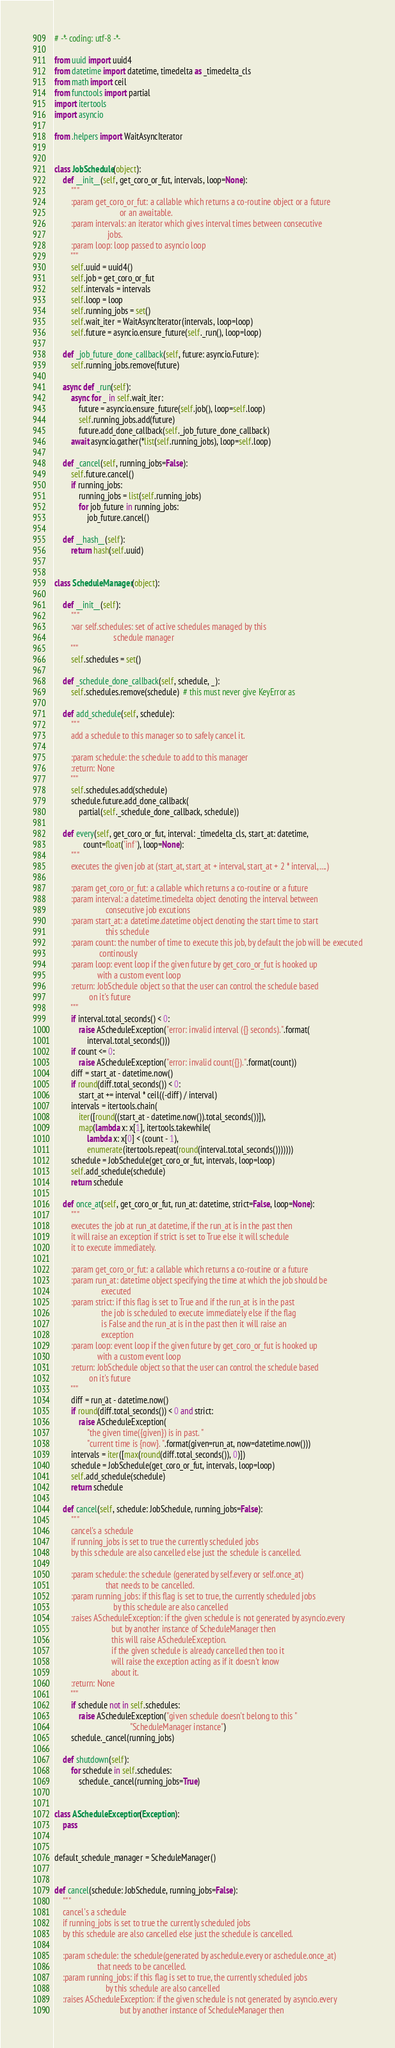<code> <loc_0><loc_0><loc_500><loc_500><_Python_># -*- coding: utf-8 -*-

from uuid import uuid4
from datetime import datetime, timedelta as _timedelta_cls
from math import ceil
from functools import partial
import itertools
import asyncio

from .helpers import WaitAsyncIterator


class JobSchedule(object):
    def __init__(self, get_coro_or_fut, intervals, loop=None):
        """
        :param get_coro_or_fut: a callable which returns a co-routine object or a future
                                or an awaitable.
        :param intervals: an iterator which gives interval times between consecutive
                          jobs.
        :param loop: loop passed to asyncio loop
        """
        self.uuid = uuid4()
        self.job = get_coro_or_fut
        self.intervals = intervals
        self.loop = loop
        self.running_jobs = set()
        self.wait_iter = WaitAsyncIterator(intervals, loop=loop)
        self.future = asyncio.ensure_future(self._run(), loop=loop)

    def _job_future_done_callback(self, future: asyncio.Future):
        self.running_jobs.remove(future)

    async def _run(self):
        async for _ in self.wait_iter:
            future = asyncio.ensure_future(self.job(), loop=self.loop)
            self.running_jobs.add(future)
            future.add_done_callback(self._job_future_done_callback)
        await asyncio.gather(*list(self.running_jobs), loop=self.loop)

    def _cancel(self, running_jobs=False):
        self.future.cancel()
        if running_jobs:
            running_jobs = list(self.running_jobs)
            for job_future in running_jobs:
                job_future.cancel()

    def __hash__(self):
        return hash(self.uuid)


class ScheduleManager(object):

    def __init__(self):
        """
        :var self.schedules: set of active schedules managed by this
                             schedule manager
        """
        self.schedules = set()

    def _schedule_done_callback(self, schedule, _):
        self.schedules.remove(schedule)  # this must never give KeyError as

    def add_schedule(self, schedule):
        """
        add a schedule to this manager so to safely cancel it.

        :param schedule: the schedule to add to this manager
        :return: None
        """
        self.schedules.add(schedule)
        schedule.future.add_done_callback(
            partial(self._schedule_done_callback, schedule))

    def every(self, get_coro_or_fut, interval: _timedelta_cls, start_at: datetime,
              count=float('inf'), loop=None):
        """
        executes the given job at (start_at, start_at + interval, start_at + 2 * interval, ....)

        :param get_coro_or_fut: a callable which returns a co-routine or a future
        :param interval: a datetime.timedelta object denoting the interval between
                         consecutive job excutions
        :param start_at: a datetime.datetime object denoting the start time to start
                         this schedule
        :param count: the number of time to execute this job, by default the job will be executed
                      continously
        :param loop: event loop if the given future by get_coro_or_fut is hooked up
                     with a custom event loop
        :return: JobSchedule object so that the user can control the schedule based
                 on it's future
        """
        if interval.total_seconds() < 0:
            raise AScheduleException("error: invalid interval ({} seconds).".format(
                interval.total_seconds()))
        if count <= 0:
            raise AScheduleException("error: invalid count({}).".format(count))
        diff = start_at - datetime.now()
        if round(diff.total_seconds()) < 0:
            start_at += interval * ceil((-diff) / interval)
        intervals = itertools.chain(
            iter([round((start_at - datetime.now()).total_seconds())]),
            map(lambda x: x[1], itertools.takewhile(
                lambda x: x[0] < (count - 1),
                enumerate(itertools.repeat(round(interval.total_seconds()))))))
        schedule = JobSchedule(get_coro_or_fut, intervals, loop=loop)
        self.add_schedule(schedule)
        return schedule

    def once_at(self, get_coro_or_fut, run_at: datetime, strict=False, loop=None):
        """
        executes the job at run_at datetime, if the run_at is in the past then
        it will raise an exception if strict is set to True else it will schedule
        it to execute immediately.

        :param get_coro_or_fut: a callable which returns a co-routine or a future
        :param run_at: datetime object specifying the time at which the job should be
                       executed
        :param strict: if this flag is set to True and if the run_at is in the past
                       the job is scheduled to execute immediately else if the flag
                       is False and the run_at is in the past then it will raise an
                       exception
        :param loop: event loop if the given future by get_coro_or_fut is hooked up
                     with a custom event loop
        :return: JobSchedule object so that the user can control the schedule based
                 on it's future
        """
        diff = run_at - datetime.now()
        if round(diff.total_seconds()) < 0 and strict:
            raise AScheduleException(
                "the given time({given}) is in past. "
                "current time is {now}. ".format(given=run_at, now=datetime.now()))
        intervals = iter([max(round(diff.total_seconds()), 0)])
        schedule = JobSchedule(get_coro_or_fut, intervals, loop=loop)
        self.add_schedule(schedule)
        return schedule

    def cancel(self, schedule: JobSchedule, running_jobs=False):
        """
        cancel's a schedule
        if running_jobs is set to true the currently scheduled jobs
        by this schedule are also cancelled else just the schedule is cancelled.

        :param schedule: the schedule (generated by self.every or self.once_at)
                         that needs to be cancelled.
        :param running_jobs: if this flag is set to true, the currently scheduled jobs
                             by this schedule are also cancelled
        :raises AScheduleException: if the given schedule is not generated by asyncio.every
                            but by another instance of ScheduleManager then
                            this will raise AScheduleException.
                            if the given schedule is already cancelled then too it
                            will raise the exception acting as if it doesn't know
                            about it.
        :return: None
        """
        if schedule not in self.schedules:
            raise AScheduleException("given schedule doesn't belong to this "
                                     "ScheduleManager instance")
        schedule._cancel(running_jobs)

    def shutdown(self):
        for schedule in self.schedules:
            schedule._cancel(running_jobs=True)


class AScheduleException(Exception):
    pass


default_schedule_manager = ScheduleManager()


def cancel(schedule: JobSchedule, running_jobs=False):
    """
    cancel's a schedule
    if running_jobs is set to true the currently scheduled jobs
    by this schedule are also cancelled else just the schedule is cancelled.

    :param schedule: the schedule(generated by aschedule.every or aschedule.once_at)
                     that needs to be cancelled.
    :param running_jobs: if this flag is set to true, the currently scheduled jobs
                         by this schedule are also cancelled
    :raises AScheduleException: if the given schedule is not generated by asyncio.every
                                but by another instance of ScheduleManager then</code> 